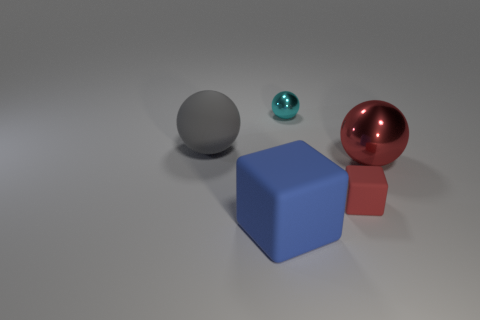There is a ball that is the same color as the small matte block; what is it made of?
Provide a short and direct response. Metal. There is a rubber object that is the same color as the big metallic ball; what size is it?
Ensure brevity in your answer.  Small. Is the size of the rubber cube behind the blue thing the same as the metallic object in front of the small cyan metallic sphere?
Your response must be concise. No. How many other things are the same shape as the gray thing?
Provide a succinct answer. 2. There is a large object in front of the big ball that is to the right of the tiny cyan object; what is it made of?
Your response must be concise. Rubber. What number of metallic things are small cyan spheres or big balls?
Make the answer very short. 2. Is there any other thing that is the same material as the large gray object?
Keep it short and to the point. Yes. There is a thing that is behind the big gray rubber ball; are there any blue objects that are on the right side of it?
Make the answer very short. No. How many objects are spheres right of the blue block or matte blocks in front of the red matte block?
Give a very brief answer. 3. Is there anything else that is the same color as the tiny metallic ball?
Give a very brief answer. No. 